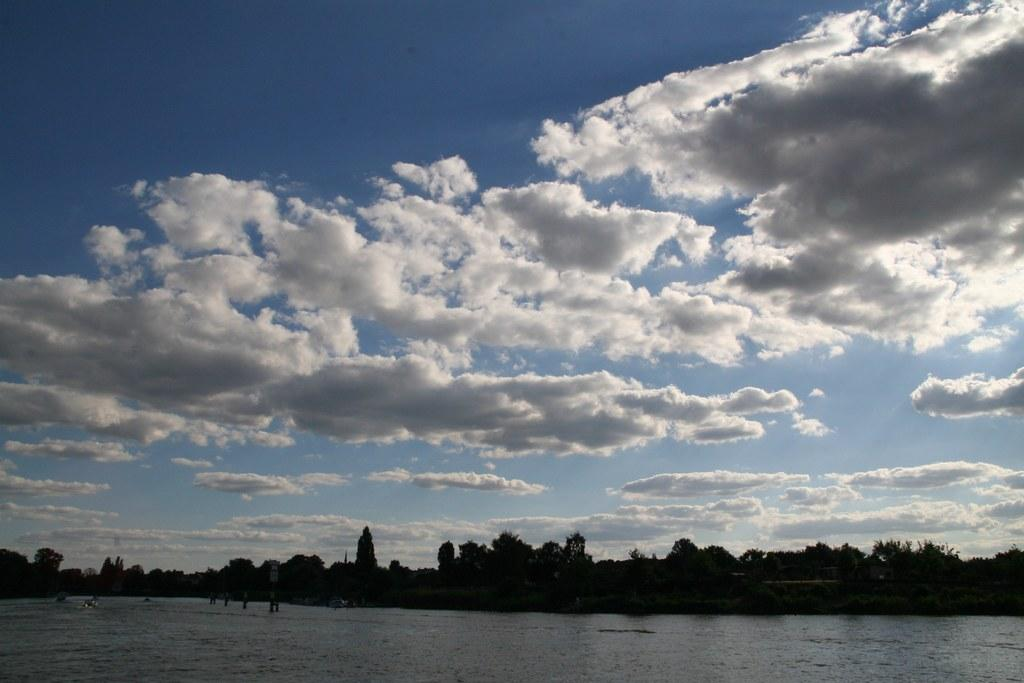What is the main feature of the image? There is a water body in the image. What can be seen behind the water body? Trees are visible behind the water body. What is the color of the sky in the image? The sky is blue in color. Are there any clouds in the sky? Yes, clouds are present in the sky. What type of breakfast is being served in the image? There is no breakfast present in the image; it features a water body, trees, and a blue sky with clouds. What amusement activity can be seen taking place in the image? There is no amusement activity depicted in the image; it shows a water body, trees, and a blue sky with clouds. 